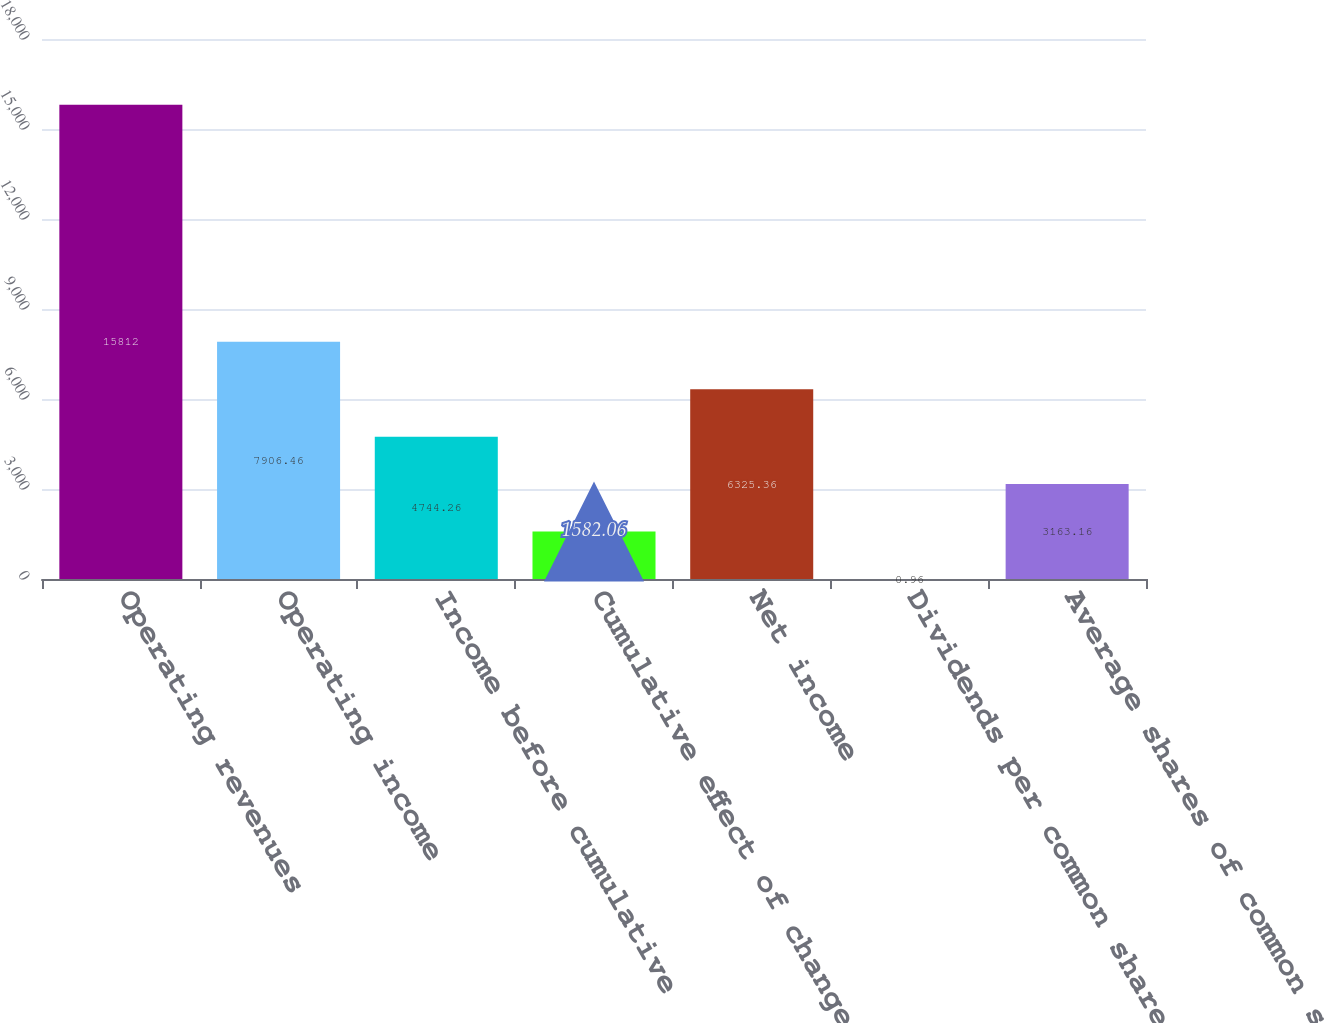Convert chart to OTSL. <chart><loc_0><loc_0><loc_500><loc_500><bar_chart><fcel>Operating revenues<fcel>Operating income<fcel>Income before cumulative<fcel>Cumulative effect of changes<fcel>Net income<fcel>Dividends per common share<fcel>Average shares of common stock<nl><fcel>15812<fcel>7906.46<fcel>4744.26<fcel>1582.06<fcel>6325.36<fcel>0.96<fcel>3163.16<nl></chart> 